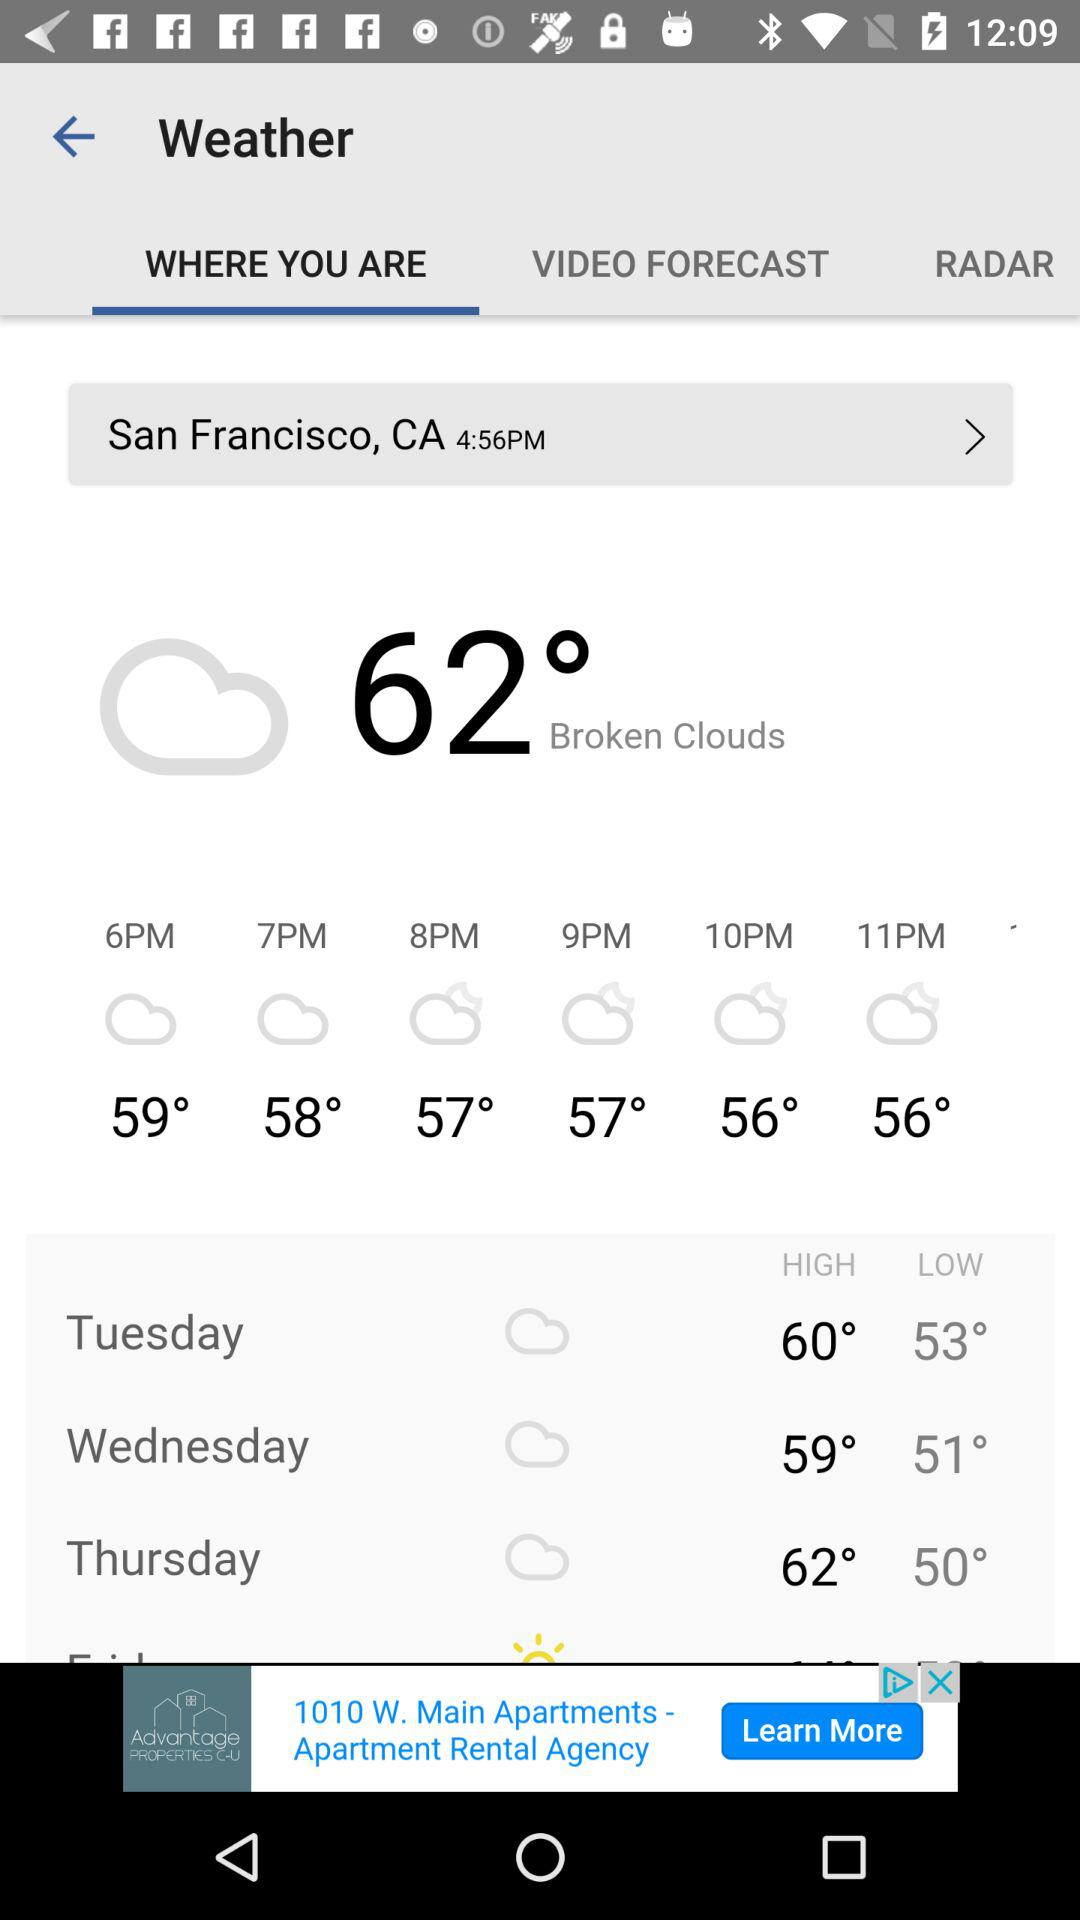What is the location? The location is San Francisco, CA. 